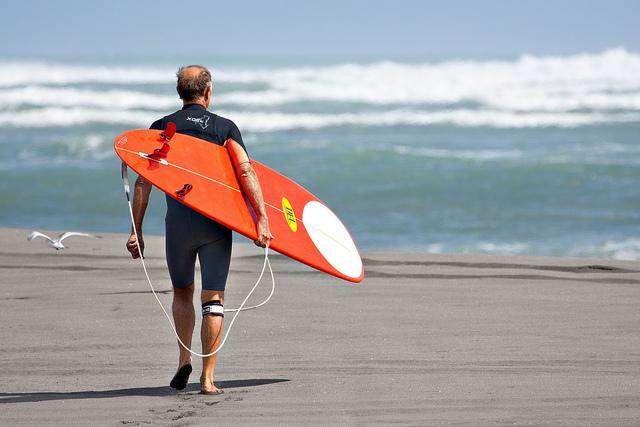What is the cable on the man's leg called? leash 